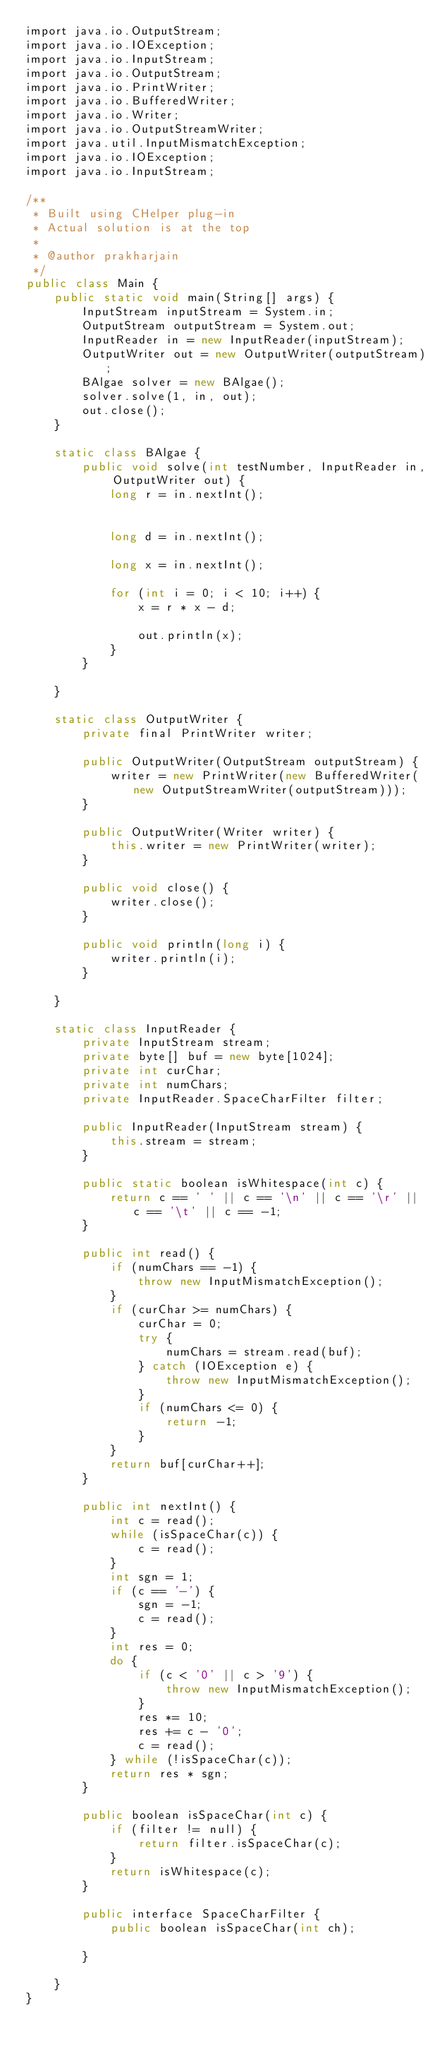Convert code to text. <code><loc_0><loc_0><loc_500><loc_500><_C++_>import java.io.OutputStream;
import java.io.IOException;
import java.io.InputStream;
import java.io.OutputStream;
import java.io.PrintWriter;
import java.io.BufferedWriter;
import java.io.Writer;
import java.io.OutputStreamWriter;
import java.util.InputMismatchException;
import java.io.IOException;
import java.io.InputStream;

/**
 * Built using CHelper plug-in
 * Actual solution is at the top
 *
 * @author prakharjain
 */
public class Main {
    public static void main(String[] args) {
        InputStream inputStream = System.in;
        OutputStream outputStream = System.out;
        InputReader in = new InputReader(inputStream);
        OutputWriter out = new OutputWriter(outputStream);
        BAlgae solver = new BAlgae();
        solver.solve(1, in, out);
        out.close();
    }

    static class BAlgae {
        public void solve(int testNumber, InputReader in, OutputWriter out) {
            long r = in.nextInt();


            long d = in.nextInt();

            long x = in.nextInt();

            for (int i = 0; i < 10; i++) {
                x = r * x - d;

                out.println(x);
            }
        }

    }

    static class OutputWriter {
        private final PrintWriter writer;

        public OutputWriter(OutputStream outputStream) {
            writer = new PrintWriter(new BufferedWriter(new OutputStreamWriter(outputStream)));
        }

        public OutputWriter(Writer writer) {
            this.writer = new PrintWriter(writer);
        }

        public void close() {
            writer.close();
        }

        public void println(long i) {
            writer.println(i);
        }

    }

    static class InputReader {
        private InputStream stream;
        private byte[] buf = new byte[1024];
        private int curChar;
        private int numChars;
        private InputReader.SpaceCharFilter filter;

        public InputReader(InputStream stream) {
            this.stream = stream;
        }

        public static boolean isWhitespace(int c) {
            return c == ' ' || c == '\n' || c == '\r' || c == '\t' || c == -1;
        }

        public int read() {
            if (numChars == -1) {
                throw new InputMismatchException();
            }
            if (curChar >= numChars) {
                curChar = 0;
                try {
                    numChars = stream.read(buf);
                } catch (IOException e) {
                    throw new InputMismatchException();
                }
                if (numChars <= 0) {
                    return -1;
                }
            }
            return buf[curChar++];
        }

        public int nextInt() {
            int c = read();
            while (isSpaceChar(c)) {
                c = read();
            }
            int sgn = 1;
            if (c == '-') {
                sgn = -1;
                c = read();
            }
            int res = 0;
            do {
                if (c < '0' || c > '9') {
                    throw new InputMismatchException();
                }
                res *= 10;
                res += c - '0';
                c = read();
            } while (!isSpaceChar(c));
            return res * sgn;
        }

        public boolean isSpaceChar(int c) {
            if (filter != null) {
                return filter.isSpaceChar(c);
            }
            return isWhitespace(c);
        }

        public interface SpaceCharFilter {
            public boolean isSpaceChar(int ch);

        }

    }
}

</code> 